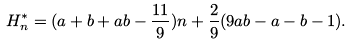Convert formula to latex. <formula><loc_0><loc_0><loc_500><loc_500>H _ { n } ^ { * } = ( a + b + a b - \frac { 1 1 } { 9 } ) n + \frac { 2 } { 9 } ( 9 a b - a - b - 1 ) .</formula> 